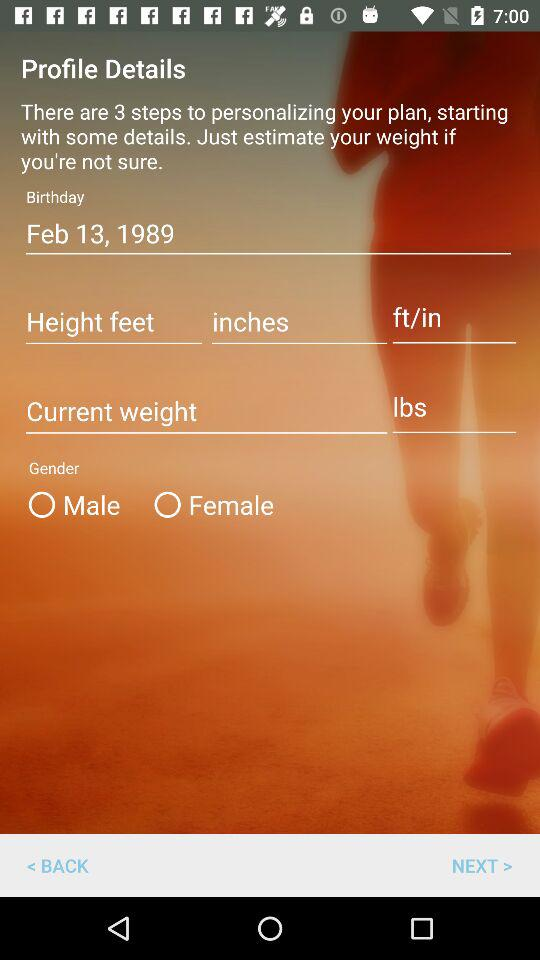What's the weight unit? The weight unit is lbs. 